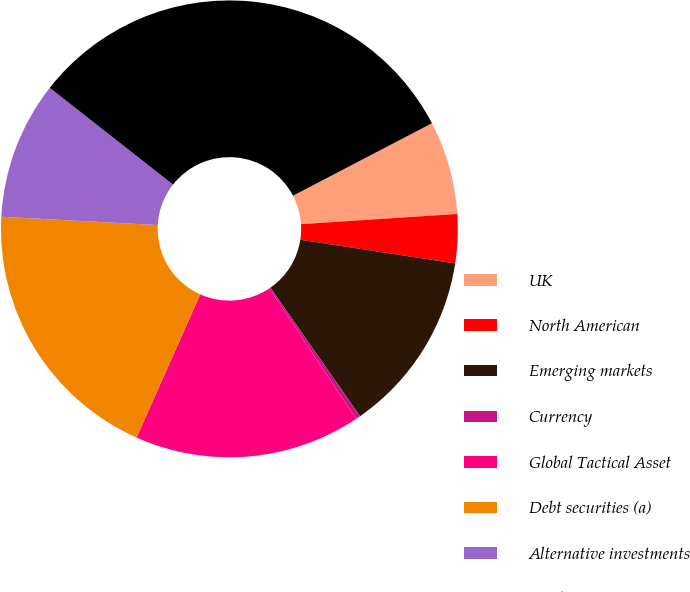<chart> <loc_0><loc_0><loc_500><loc_500><pie_chart><fcel>UK<fcel>North American<fcel>Emerging markets<fcel>Currency<fcel>Global Tactical Asset<fcel>Debt securities (a)<fcel>Alternative investments<fcel>Total<nl><fcel>6.61%<fcel>3.46%<fcel>12.89%<fcel>0.32%<fcel>16.04%<fcel>19.18%<fcel>9.75%<fcel>31.76%<nl></chart> 